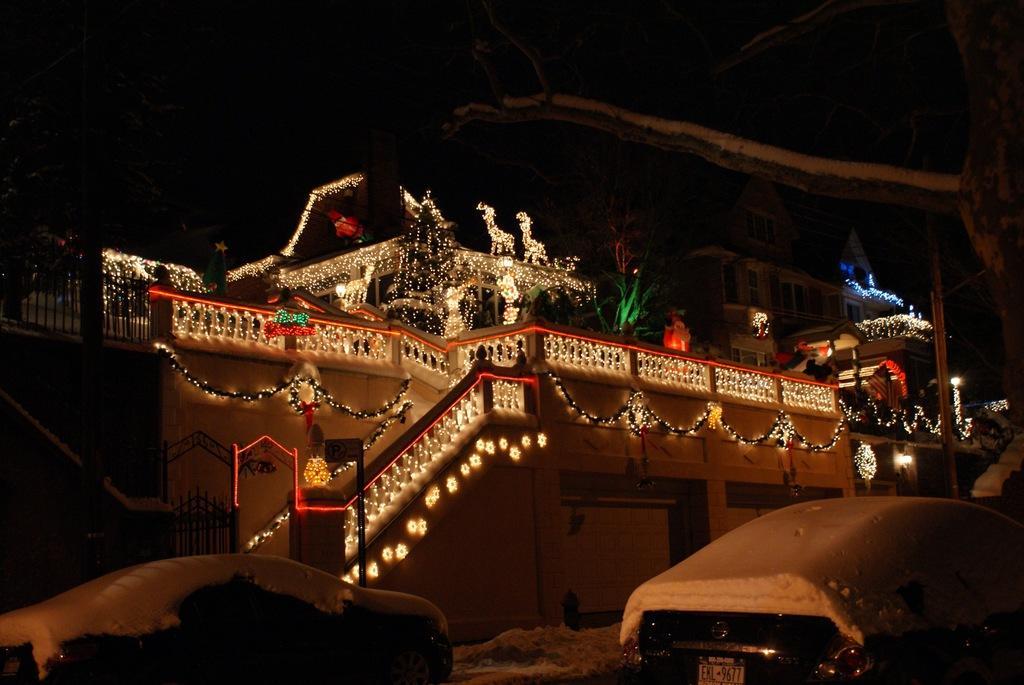Describe this image in one or two sentences. In this image, we can see a few buildings, walls, railings, trees, decorative objects, grills and poles. At the bottom, we can see vehicles are covered with snow. Background there is a dark view. 